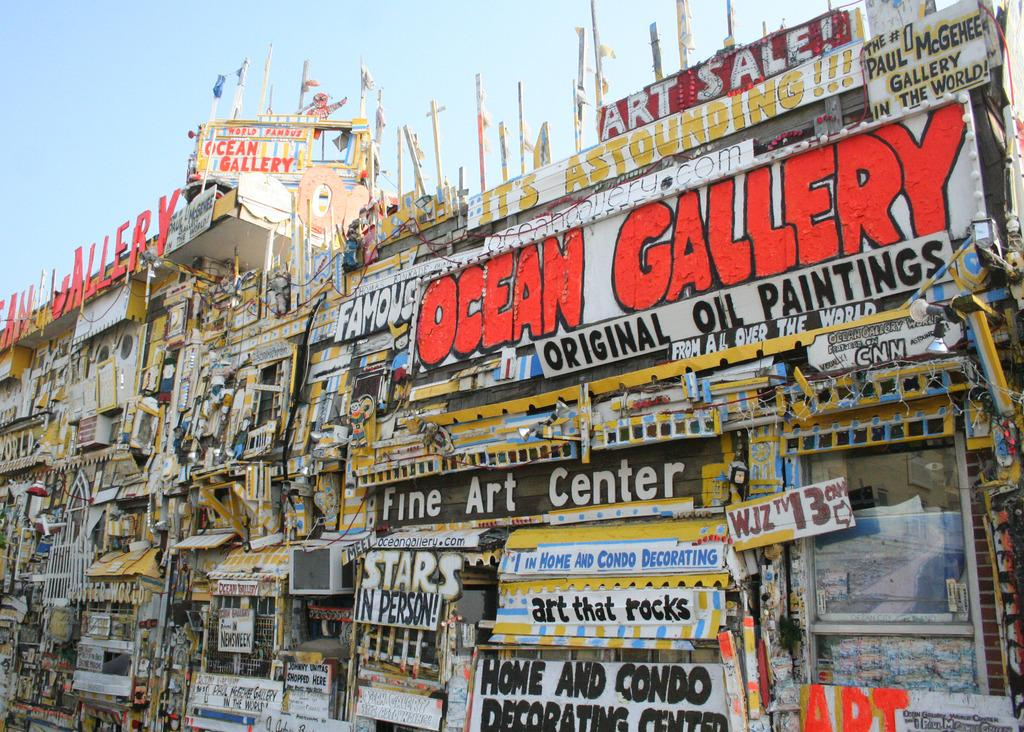What can be seen on the buildings in the image? There are boards and posters with text on the buildings. Are there any other structures or objects on the buildings? Yes, there are poles on the buildings. Can you see a pet playing with a cup on one of the buildings in the image? No, there is no pet or cup present on the buildings in the image. 